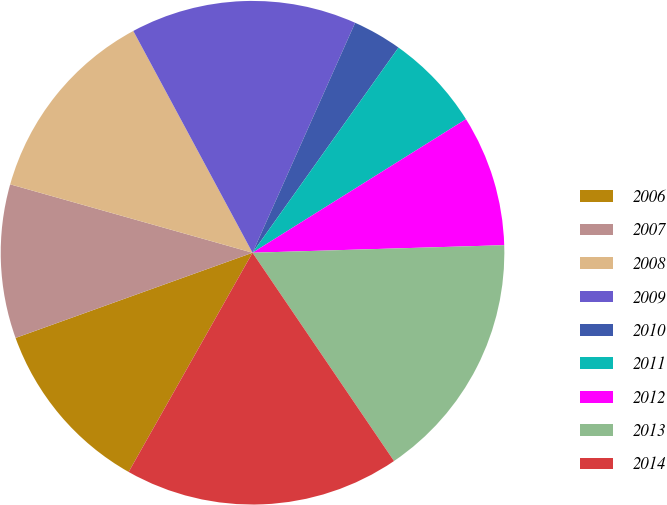<chart> <loc_0><loc_0><loc_500><loc_500><pie_chart><fcel>2006<fcel>2007<fcel>2008<fcel>2009<fcel>2010<fcel>2011<fcel>2012<fcel>2013<fcel>2014<nl><fcel>11.32%<fcel>9.87%<fcel>12.77%<fcel>14.53%<fcel>3.16%<fcel>6.26%<fcel>8.42%<fcel>15.98%<fcel>17.68%<nl></chart> 